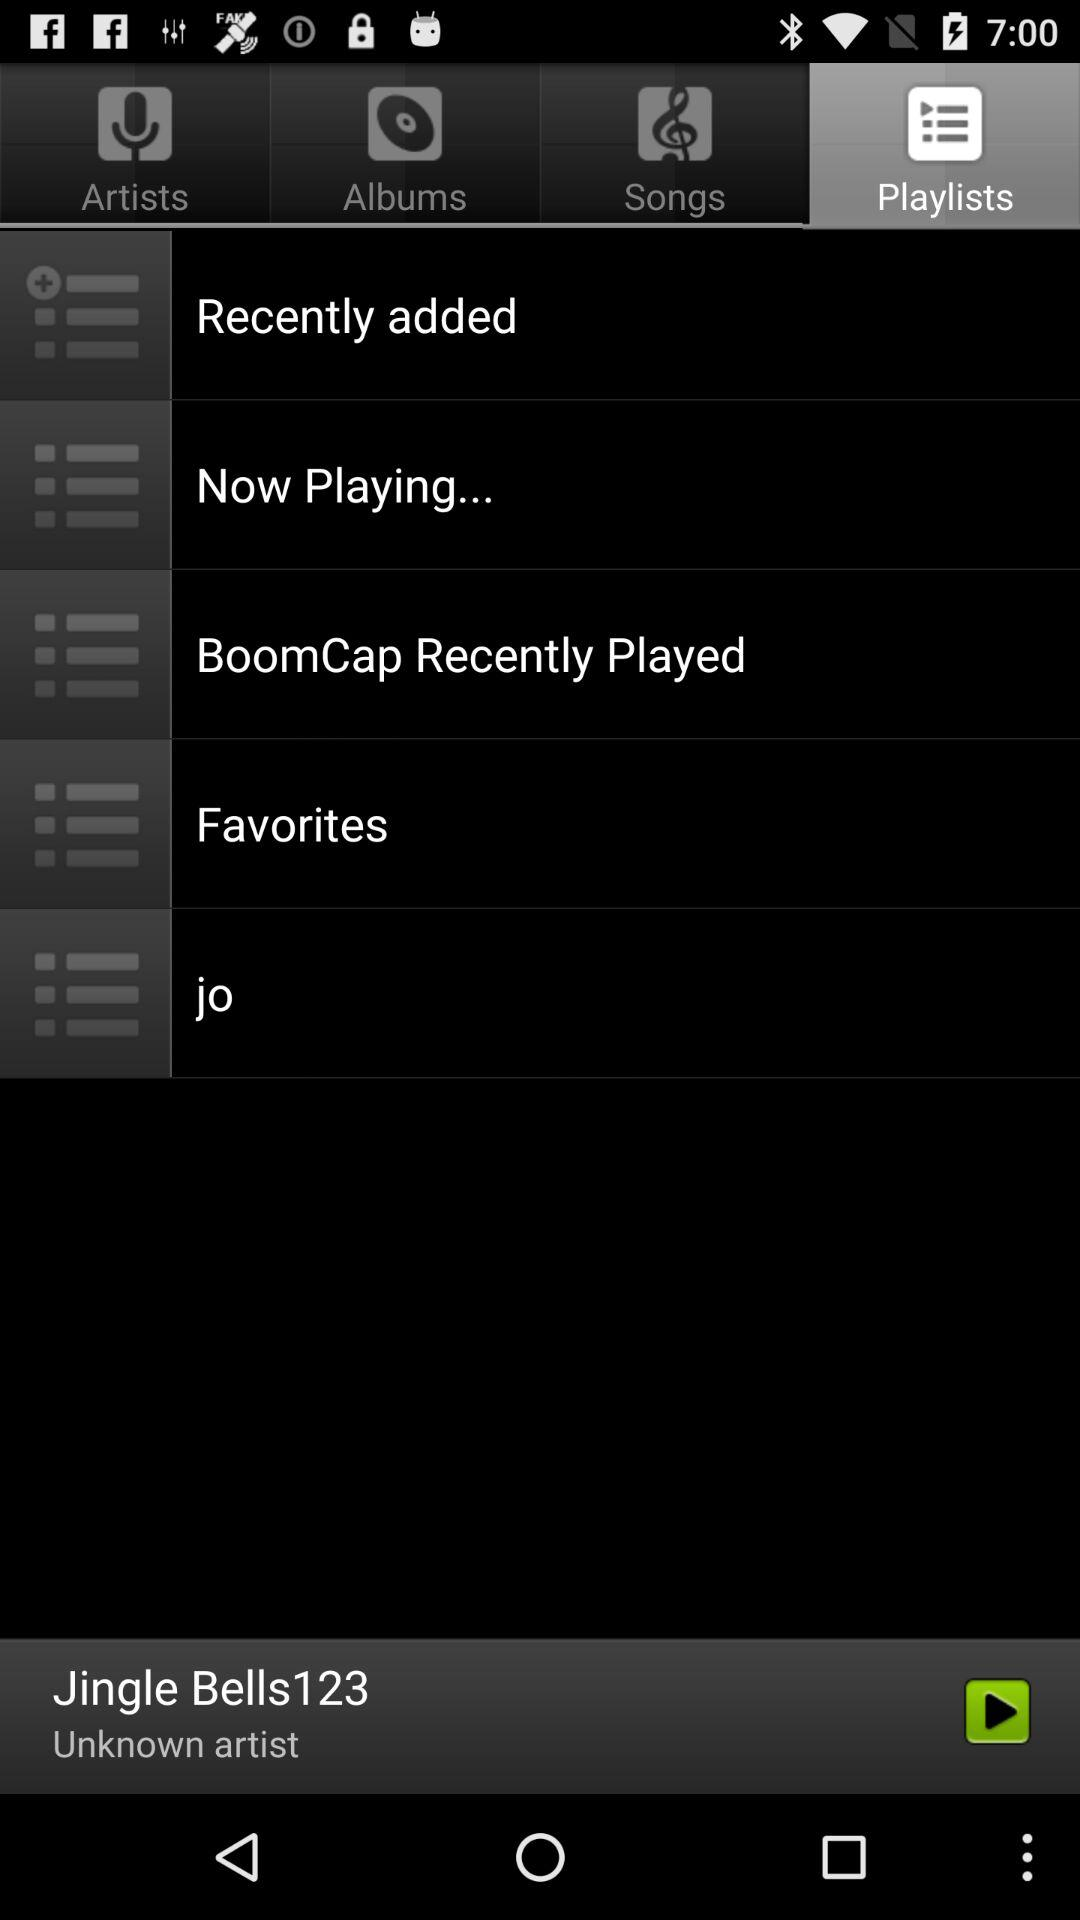Who's the artist of Jingle Bells123? The artist is unknown. 